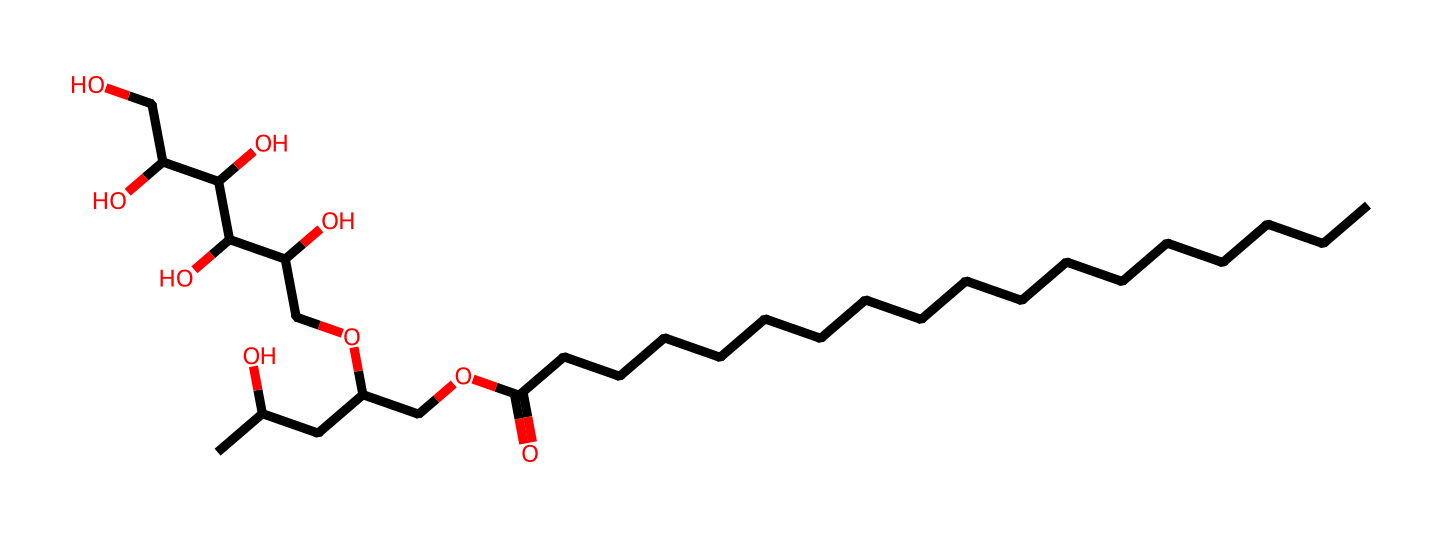What is the main functional group present in polysorbate 20? The main functional group observed in the structure is the ester group, indicated by the -O-C(=O)- linkage between the fatty acid and the polyol portions of the molecule.
Answer: ester How many carbon atoms are present in polysorbate 20? By analyzing the SMILES representation, we can count a total of 20 carbon atoms, which are derived from both the long hydrocarbon chain and the sugar alcohol components.
Answer: 20 What type of surfactant is polysorbate 20? Polysorbate 20 is classified as a nonionic surfactant due to the absence of charged groups in its structure, making it less sensitive to changes in pH and electrolyte concentration.
Answer: nonionic Which part of polysorbate 20 contributes to its emulsifying properties? The polyol and the ester linkages contribute significantly to the emulsifying properties, as these structures can help to stabilize oil-water mixtures by reducing surface tension.
Answer: polyol How many hydroxyl (OH) groups are present in polysorbate 20? By examining the structure, there are 4 hydroxyl groups present in the sugar alcohol portion, enhancing its hydrophilic characteristics.
Answer: 4 